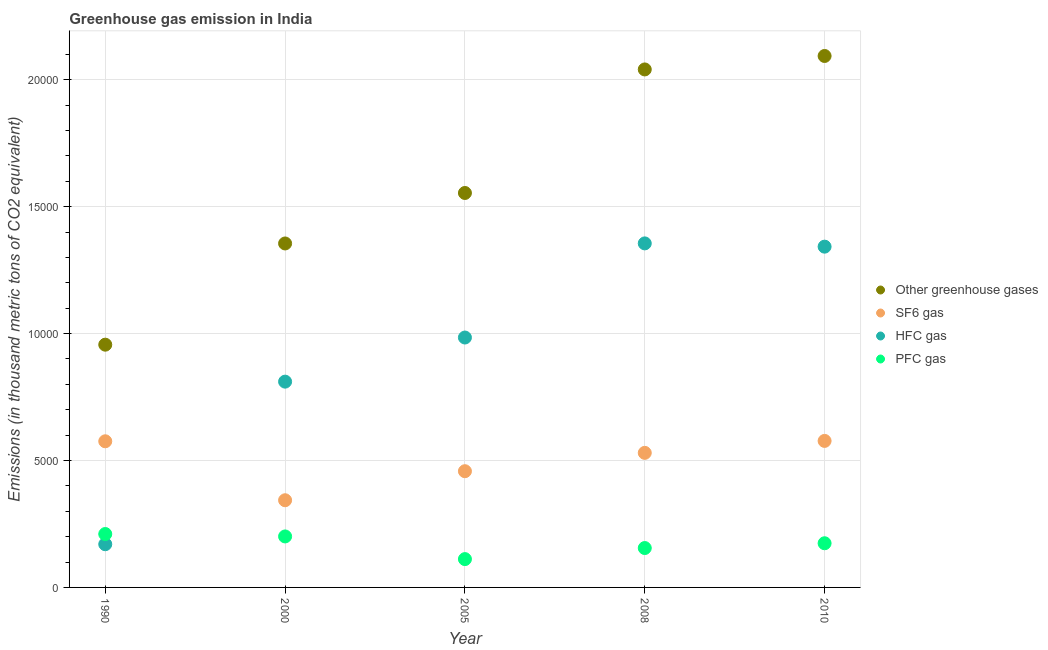Is the number of dotlines equal to the number of legend labels?
Your response must be concise. Yes. What is the emission of pfc gas in 1990?
Provide a succinct answer. 2104. Across all years, what is the maximum emission of pfc gas?
Ensure brevity in your answer.  2104. Across all years, what is the minimum emission of pfc gas?
Your answer should be compact. 1115.8. In which year was the emission of greenhouse gases maximum?
Make the answer very short. 2010. In which year was the emission of pfc gas minimum?
Provide a succinct answer. 2005. What is the total emission of sf6 gas in the graph?
Offer a very short reply. 2.48e+04. What is the difference between the emission of greenhouse gases in 1990 and that in 2008?
Your response must be concise. -1.08e+04. What is the difference between the emission of sf6 gas in 1990 and the emission of greenhouse gases in 2008?
Make the answer very short. -1.46e+04. What is the average emission of greenhouse gases per year?
Give a very brief answer. 1.60e+04. In the year 2005, what is the difference between the emission of sf6 gas and emission of greenhouse gases?
Keep it short and to the point. -1.10e+04. What is the ratio of the emission of hfc gas in 2008 to that in 2010?
Give a very brief answer. 1.01. Is the difference between the emission of pfc gas in 2000 and 2005 greater than the difference between the emission of greenhouse gases in 2000 and 2005?
Offer a terse response. Yes. What is the difference between the highest and the second highest emission of pfc gas?
Give a very brief answer. 95.2. What is the difference between the highest and the lowest emission of greenhouse gases?
Provide a succinct answer. 1.14e+04. In how many years, is the emission of pfc gas greater than the average emission of pfc gas taken over all years?
Offer a terse response. 3. Is it the case that in every year, the sum of the emission of greenhouse gases and emission of hfc gas is greater than the sum of emission of sf6 gas and emission of pfc gas?
Make the answer very short. No. Does the emission of greenhouse gases monotonically increase over the years?
Ensure brevity in your answer.  Yes. How many years are there in the graph?
Make the answer very short. 5. Are the values on the major ticks of Y-axis written in scientific E-notation?
Your answer should be compact. No. Where does the legend appear in the graph?
Provide a short and direct response. Center right. What is the title of the graph?
Make the answer very short. Greenhouse gas emission in India. Does "Social Insurance" appear as one of the legend labels in the graph?
Offer a very short reply. No. What is the label or title of the X-axis?
Your answer should be compact. Year. What is the label or title of the Y-axis?
Your response must be concise. Emissions (in thousand metric tons of CO2 equivalent). What is the Emissions (in thousand metric tons of CO2 equivalent) of Other greenhouse gases in 1990?
Give a very brief answer. 9563.6. What is the Emissions (in thousand metric tons of CO2 equivalent) in SF6 gas in 1990?
Offer a terse response. 5757.5. What is the Emissions (in thousand metric tons of CO2 equivalent) in HFC gas in 1990?
Provide a short and direct response. 1702.1. What is the Emissions (in thousand metric tons of CO2 equivalent) of PFC gas in 1990?
Offer a very short reply. 2104. What is the Emissions (in thousand metric tons of CO2 equivalent) in Other greenhouse gases in 2000?
Give a very brief answer. 1.36e+04. What is the Emissions (in thousand metric tons of CO2 equivalent) in SF6 gas in 2000?
Your response must be concise. 3434.7. What is the Emissions (in thousand metric tons of CO2 equivalent) in HFC gas in 2000?
Keep it short and to the point. 8107.2. What is the Emissions (in thousand metric tons of CO2 equivalent) in PFC gas in 2000?
Ensure brevity in your answer.  2008.8. What is the Emissions (in thousand metric tons of CO2 equivalent) in Other greenhouse gases in 2005?
Your answer should be compact. 1.55e+04. What is the Emissions (in thousand metric tons of CO2 equivalent) in SF6 gas in 2005?
Provide a succinct answer. 4578.7. What is the Emissions (in thousand metric tons of CO2 equivalent) in HFC gas in 2005?
Your answer should be compact. 9845.2. What is the Emissions (in thousand metric tons of CO2 equivalent) in PFC gas in 2005?
Offer a very short reply. 1115.8. What is the Emissions (in thousand metric tons of CO2 equivalent) in Other greenhouse gases in 2008?
Make the answer very short. 2.04e+04. What is the Emissions (in thousand metric tons of CO2 equivalent) of SF6 gas in 2008?
Give a very brief answer. 5301.4. What is the Emissions (in thousand metric tons of CO2 equivalent) in HFC gas in 2008?
Your answer should be compact. 1.36e+04. What is the Emissions (in thousand metric tons of CO2 equivalent) in PFC gas in 2008?
Provide a succinct answer. 1551.8. What is the Emissions (in thousand metric tons of CO2 equivalent) in Other greenhouse gases in 2010?
Provide a succinct answer. 2.09e+04. What is the Emissions (in thousand metric tons of CO2 equivalent) of SF6 gas in 2010?
Provide a succinct answer. 5772. What is the Emissions (in thousand metric tons of CO2 equivalent) in HFC gas in 2010?
Provide a short and direct response. 1.34e+04. What is the Emissions (in thousand metric tons of CO2 equivalent) in PFC gas in 2010?
Offer a terse response. 1740. Across all years, what is the maximum Emissions (in thousand metric tons of CO2 equivalent) of Other greenhouse gases?
Your answer should be very brief. 2.09e+04. Across all years, what is the maximum Emissions (in thousand metric tons of CO2 equivalent) of SF6 gas?
Your response must be concise. 5772. Across all years, what is the maximum Emissions (in thousand metric tons of CO2 equivalent) in HFC gas?
Offer a terse response. 1.36e+04. Across all years, what is the maximum Emissions (in thousand metric tons of CO2 equivalent) in PFC gas?
Provide a short and direct response. 2104. Across all years, what is the minimum Emissions (in thousand metric tons of CO2 equivalent) in Other greenhouse gases?
Make the answer very short. 9563.6. Across all years, what is the minimum Emissions (in thousand metric tons of CO2 equivalent) in SF6 gas?
Provide a short and direct response. 3434.7. Across all years, what is the minimum Emissions (in thousand metric tons of CO2 equivalent) in HFC gas?
Provide a succinct answer. 1702.1. Across all years, what is the minimum Emissions (in thousand metric tons of CO2 equivalent) of PFC gas?
Your response must be concise. 1115.8. What is the total Emissions (in thousand metric tons of CO2 equivalent) in Other greenhouse gases in the graph?
Offer a terse response. 8.00e+04. What is the total Emissions (in thousand metric tons of CO2 equivalent) of SF6 gas in the graph?
Your answer should be very brief. 2.48e+04. What is the total Emissions (in thousand metric tons of CO2 equivalent) in HFC gas in the graph?
Offer a very short reply. 4.66e+04. What is the total Emissions (in thousand metric tons of CO2 equivalent) in PFC gas in the graph?
Your answer should be compact. 8520.4. What is the difference between the Emissions (in thousand metric tons of CO2 equivalent) of Other greenhouse gases in 1990 and that in 2000?
Your answer should be very brief. -3987.1. What is the difference between the Emissions (in thousand metric tons of CO2 equivalent) in SF6 gas in 1990 and that in 2000?
Provide a succinct answer. 2322.8. What is the difference between the Emissions (in thousand metric tons of CO2 equivalent) in HFC gas in 1990 and that in 2000?
Make the answer very short. -6405.1. What is the difference between the Emissions (in thousand metric tons of CO2 equivalent) of PFC gas in 1990 and that in 2000?
Your answer should be compact. 95.2. What is the difference between the Emissions (in thousand metric tons of CO2 equivalent) of Other greenhouse gases in 1990 and that in 2005?
Provide a succinct answer. -5976.1. What is the difference between the Emissions (in thousand metric tons of CO2 equivalent) of SF6 gas in 1990 and that in 2005?
Provide a succinct answer. 1178.8. What is the difference between the Emissions (in thousand metric tons of CO2 equivalent) in HFC gas in 1990 and that in 2005?
Give a very brief answer. -8143.1. What is the difference between the Emissions (in thousand metric tons of CO2 equivalent) in PFC gas in 1990 and that in 2005?
Your answer should be compact. 988.2. What is the difference between the Emissions (in thousand metric tons of CO2 equivalent) in Other greenhouse gases in 1990 and that in 2008?
Keep it short and to the point. -1.08e+04. What is the difference between the Emissions (in thousand metric tons of CO2 equivalent) of SF6 gas in 1990 and that in 2008?
Keep it short and to the point. 456.1. What is the difference between the Emissions (in thousand metric tons of CO2 equivalent) in HFC gas in 1990 and that in 2008?
Ensure brevity in your answer.  -1.19e+04. What is the difference between the Emissions (in thousand metric tons of CO2 equivalent) of PFC gas in 1990 and that in 2008?
Keep it short and to the point. 552.2. What is the difference between the Emissions (in thousand metric tons of CO2 equivalent) in Other greenhouse gases in 1990 and that in 2010?
Your answer should be compact. -1.14e+04. What is the difference between the Emissions (in thousand metric tons of CO2 equivalent) of SF6 gas in 1990 and that in 2010?
Provide a succinct answer. -14.5. What is the difference between the Emissions (in thousand metric tons of CO2 equivalent) in HFC gas in 1990 and that in 2010?
Provide a succinct answer. -1.17e+04. What is the difference between the Emissions (in thousand metric tons of CO2 equivalent) of PFC gas in 1990 and that in 2010?
Make the answer very short. 364. What is the difference between the Emissions (in thousand metric tons of CO2 equivalent) in Other greenhouse gases in 2000 and that in 2005?
Your answer should be very brief. -1989. What is the difference between the Emissions (in thousand metric tons of CO2 equivalent) in SF6 gas in 2000 and that in 2005?
Your answer should be very brief. -1144. What is the difference between the Emissions (in thousand metric tons of CO2 equivalent) of HFC gas in 2000 and that in 2005?
Your response must be concise. -1738. What is the difference between the Emissions (in thousand metric tons of CO2 equivalent) in PFC gas in 2000 and that in 2005?
Your answer should be very brief. 893. What is the difference between the Emissions (in thousand metric tons of CO2 equivalent) of Other greenhouse gases in 2000 and that in 2008?
Provide a succinct answer. -6856.2. What is the difference between the Emissions (in thousand metric tons of CO2 equivalent) of SF6 gas in 2000 and that in 2008?
Provide a succinct answer. -1866.7. What is the difference between the Emissions (in thousand metric tons of CO2 equivalent) in HFC gas in 2000 and that in 2008?
Offer a terse response. -5446.5. What is the difference between the Emissions (in thousand metric tons of CO2 equivalent) of PFC gas in 2000 and that in 2008?
Provide a short and direct response. 457. What is the difference between the Emissions (in thousand metric tons of CO2 equivalent) of Other greenhouse gases in 2000 and that in 2010?
Make the answer very short. -7386.3. What is the difference between the Emissions (in thousand metric tons of CO2 equivalent) in SF6 gas in 2000 and that in 2010?
Ensure brevity in your answer.  -2337.3. What is the difference between the Emissions (in thousand metric tons of CO2 equivalent) in HFC gas in 2000 and that in 2010?
Your answer should be compact. -5317.8. What is the difference between the Emissions (in thousand metric tons of CO2 equivalent) in PFC gas in 2000 and that in 2010?
Offer a terse response. 268.8. What is the difference between the Emissions (in thousand metric tons of CO2 equivalent) in Other greenhouse gases in 2005 and that in 2008?
Your response must be concise. -4867.2. What is the difference between the Emissions (in thousand metric tons of CO2 equivalent) in SF6 gas in 2005 and that in 2008?
Make the answer very short. -722.7. What is the difference between the Emissions (in thousand metric tons of CO2 equivalent) of HFC gas in 2005 and that in 2008?
Provide a succinct answer. -3708.5. What is the difference between the Emissions (in thousand metric tons of CO2 equivalent) of PFC gas in 2005 and that in 2008?
Your answer should be compact. -436. What is the difference between the Emissions (in thousand metric tons of CO2 equivalent) of Other greenhouse gases in 2005 and that in 2010?
Your answer should be very brief. -5397.3. What is the difference between the Emissions (in thousand metric tons of CO2 equivalent) of SF6 gas in 2005 and that in 2010?
Your answer should be compact. -1193.3. What is the difference between the Emissions (in thousand metric tons of CO2 equivalent) in HFC gas in 2005 and that in 2010?
Offer a terse response. -3579.8. What is the difference between the Emissions (in thousand metric tons of CO2 equivalent) of PFC gas in 2005 and that in 2010?
Provide a succinct answer. -624.2. What is the difference between the Emissions (in thousand metric tons of CO2 equivalent) in Other greenhouse gases in 2008 and that in 2010?
Your answer should be very brief. -530.1. What is the difference between the Emissions (in thousand metric tons of CO2 equivalent) of SF6 gas in 2008 and that in 2010?
Provide a succinct answer. -470.6. What is the difference between the Emissions (in thousand metric tons of CO2 equivalent) in HFC gas in 2008 and that in 2010?
Your answer should be very brief. 128.7. What is the difference between the Emissions (in thousand metric tons of CO2 equivalent) in PFC gas in 2008 and that in 2010?
Your response must be concise. -188.2. What is the difference between the Emissions (in thousand metric tons of CO2 equivalent) in Other greenhouse gases in 1990 and the Emissions (in thousand metric tons of CO2 equivalent) in SF6 gas in 2000?
Your response must be concise. 6128.9. What is the difference between the Emissions (in thousand metric tons of CO2 equivalent) in Other greenhouse gases in 1990 and the Emissions (in thousand metric tons of CO2 equivalent) in HFC gas in 2000?
Your response must be concise. 1456.4. What is the difference between the Emissions (in thousand metric tons of CO2 equivalent) in Other greenhouse gases in 1990 and the Emissions (in thousand metric tons of CO2 equivalent) in PFC gas in 2000?
Your response must be concise. 7554.8. What is the difference between the Emissions (in thousand metric tons of CO2 equivalent) in SF6 gas in 1990 and the Emissions (in thousand metric tons of CO2 equivalent) in HFC gas in 2000?
Provide a short and direct response. -2349.7. What is the difference between the Emissions (in thousand metric tons of CO2 equivalent) in SF6 gas in 1990 and the Emissions (in thousand metric tons of CO2 equivalent) in PFC gas in 2000?
Offer a very short reply. 3748.7. What is the difference between the Emissions (in thousand metric tons of CO2 equivalent) of HFC gas in 1990 and the Emissions (in thousand metric tons of CO2 equivalent) of PFC gas in 2000?
Offer a very short reply. -306.7. What is the difference between the Emissions (in thousand metric tons of CO2 equivalent) of Other greenhouse gases in 1990 and the Emissions (in thousand metric tons of CO2 equivalent) of SF6 gas in 2005?
Make the answer very short. 4984.9. What is the difference between the Emissions (in thousand metric tons of CO2 equivalent) of Other greenhouse gases in 1990 and the Emissions (in thousand metric tons of CO2 equivalent) of HFC gas in 2005?
Your answer should be compact. -281.6. What is the difference between the Emissions (in thousand metric tons of CO2 equivalent) of Other greenhouse gases in 1990 and the Emissions (in thousand metric tons of CO2 equivalent) of PFC gas in 2005?
Offer a terse response. 8447.8. What is the difference between the Emissions (in thousand metric tons of CO2 equivalent) in SF6 gas in 1990 and the Emissions (in thousand metric tons of CO2 equivalent) in HFC gas in 2005?
Provide a short and direct response. -4087.7. What is the difference between the Emissions (in thousand metric tons of CO2 equivalent) in SF6 gas in 1990 and the Emissions (in thousand metric tons of CO2 equivalent) in PFC gas in 2005?
Your answer should be very brief. 4641.7. What is the difference between the Emissions (in thousand metric tons of CO2 equivalent) of HFC gas in 1990 and the Emissions (in thousand metric tons of CO2 equivalent) of PFC gas in 2005?
Make the answer very short. 586.3. What is the difference between the Emissions (in thousand metric tons of CO2 equivalent) of Other greenhouse gases in 1990 and the Emissions (in thousand metric tons of CO2 equivalent) of SF6 gas in 2008?
Give a very brief answer. 4262.2. What is the difference between the Emissions (in thousand metric tons of CO2 equivalent) of Other greenhouse gases in 1990 and the Emissions (in thousand metric tons of CO2 equivalent) of HFC gas in 2008?
Make the answer very short. -3990.1. What is the difference between the Emissions (in thousand metric tons of CO2 equivalent) in Other greenhouse gases in 1990 and the Emissions (in thousand metric tons of CO2 equivalent) in PFC gas in 2008?
Offer a very short reply. 8011.8. What is the difference between the Emissions (in thousand metric tons of CO2 equivalent) of SF6 gas in 1990 and the Emissions (in thousand metric tons of CO2 equivalent) of HFC gas in 2008?
Give a very brief answer. -7796.2. What is the difference between the Emissions (in thousand metric tons of CO2 equivalent) of SF6 gas in 1990 and the Emissions (in thousand metric tons of CO2 equivalent) of PFC gas in 2008?
Offer a very short reply. 4205.7. What is the difference between the Emissions (in thousand metric tons of CO2 equivalent) of HFC gas in 1990 and the Emissions (in thousand metric tons of CO2 equivalent) of PFC gas in 2008?
Provide a succinct answer. 150.3. What is the difference between the Emissions (in thousand metric tons of CO2 equivalent) in Other greenhouse gases in 1990 and the Emissions (in thousand metric tons of CO2 equivalent) in SF6 gas in 2010?
Provide a short and direct response. 3791.6. What is the difference between the Emissions (in thousand metric tons of CO2 equivalent) in Other greenhouse gases in 1990 and the Emissions (in thousand metric tons of CO2 equivalent) in HFC gas in 2010?
Keep it short and to the point. -3861.4. What is the difference between the Emissions (in thousand metric tons of CO2 equivalent) of Other greenhouse gases in 1990 and the Emissions (in thousand metric tons of CO2 equivalent) of PFC gas in 2010?
Provide a short and direct response. 7823.6. What is the difference between the Emissions (in thousand metric tons of CO2 equivalent) in SF6 gas in 1990 and the Emissions (in thousand metric tons of CO2 equivalent) in HFC gas in 2010?
Provide a short and direct response. -7667.5. What is the difference between the Emissions (in thousand metric tons of CO2 equivalent) in SF6 gas in 1990 and the Emissions (in thousand metric tons of CO2 equivalent) in PFC gas in 2010?
Give a very brief answer. 4017.5. What is the difference between the Emissions (in thousand metric tons of CO2 equivalent) in HFC gas in 1990 and the Emissions (in thousand metric tons of CO2 equivalent) in PFC gas in 2010?
Offer a very short reply. -37.9. What is the difference between the Emissions (in thousand metric tons of CO2 equivalent) in Other greenhouse gases in 2000 and the Emissions (in thousand metric tons of CO2 equivalent) in SF6 gas in 2005?
Provide a short and direct response. 8972. What is the difference between the Emissions (in thousand metric tons of CO2 equivalent) of Other greenhouse gases in 2000 and the Emissions (in thousand metric tons of CO2 equivalent) of HFC gas in 2005?
Offer a terse response. 3705.5. What is the difference between the Emissions (in thousand metric tons of CO2 equivalent) of Other greenhouse gases in 2000 and the Emissions (in thousand metric tons of CO2 equivalent) of PFC gas in 2005?
Offer a terse response. 1.24e+04. What is the difference between the Emissions (in thousand metric tons of CO2 equivalent) in SF6 gas in 2000 and the Emissions (in thousand metric tons of CO2 equivalent) in HFC gas in 2005?
Keep it short and to the point. -6410.5. What is the difference between the Emissions (in thousand metric tons of CO2 equivalent) in SF6 gas in 2000 and the Emissions (in thousand metric tons of CO2 equivalent) in PFC gas in 2005?
Ensure brevity in your answer.  2318.9. What is the difference between the Emissions (in thousand metric tons of CO2 equivalent) of HFC gas in 2000 and the Emissions (in thousand metric tons of CO2 equivalent) of PFC gas in 2005?
Keep it short and to the point. 6991.4. What is the difference between the Emissions (in thousand metric tons of CO2 equivalent) in Other greenhouse gases in 2000 and the Emissions (in thousand metric tons of CO2 equivalent) in SF6 gas in 2008?
Provide a short and direct response. 8249.3. What is the difference between the Emissions (in thousand metric tons of CO2 equivalent) in Other greenhouse gases in 2000 and the Emissions (in thousand metric tons of CO2 equivalent) in PFC gas in 2008?
Offer a very short reply. 1.20e+04. What is the difference between the Emissions (in thousand metric tons of CO2 equivalent) in SF6 gas in 2000 and the Emissions (in thousand metric tons of CO2 equivalent) in HFC gas in 2008?
Your response must be concise. -1.01e+04. What is the difference between the Emissions (in thousand metric tons of CO2 equivalent) in SF6 gas in 2000 and the Emissions (in thousand metric tons of CO2 equivalent) in PFC gas in 2008?
Keep it short and to the point. 1882.9. What is the difference between the Emissions (in thousand metric tons of CO2 equivalent) of HFC gas in 2000 and the Emissions (in thousand metric tons of CO2 equivalent) of PFC gas in 2008?
Ensure brevity in your answer.  6555.4. What is the difference between the Emissions (in thousand metric tons of CO2 equivalent) of Other greenhouse gases in 2000 and the Emissions (in thousand metric tons of CO2 equivalent) of SF6 gas in 2010?
Provide a succinct answer. 7778.7. What is the difference between the Emissions (in thousand metric tons of CO2 equivalent) in Other greenhouse gases in 2000 and the Emissions (in thousand metric tons of CO2 equivalent) in HFC gas in 2010?
Offer a terse response. 125.7. What is the difference between the Emissions (in thousand metric tons of CO2 equivalent) in Other greenhouse gases in 2000 and the Emissions (in thousand metric tons of CO2 equivalent) in PFC gas in 2010?
Your response must be concise. 1.18e+04. What is the difference between the Emissions (in thousand metric tons of CO2 equivalent) of SF6 gas in 2000 and the Emissions (in thousand metric tons of CO2 equivalent) of HFC gas in 2010?
Your answer should be very brief. -9990.3. What is the difference between the Emissions (in thousand metric tons of CO2 equivalent) of SF6 gas in 2000 and the Emissions (in thousand metric tons of CO2 equivalent) of PFC gas in 2010?
Offer a very short reply. 1694.7. What is the difference between the Emissions (in thousand metric tons of CO2 equivalent) in HFC gas in 2000 and the Emissions (in thousand metric tons of CO2 equivalent) in PFC gas in 2010?
Your response must be concise. 6367.2. What is the difference between the Emissions (in thousand metric tons of CO2 equivalent) in Other greenhouse gases in 2005 and the Emissions (in thousand metric tons of CO2 equivalent) in SF6 gas in 2008?
Offer a very short reply. 1.02e+04. What is the difference between the Emissions (in thousand metric tons of CO2 equivalent) in Other greenhouse gases in 2005 and the Emissions (in thousand metric tons of CO2 equivalent) in HFC gas in 2008?
Provide a succinct answer. 1986. What is the difference between the Emissions (in thousand metric tons of CO2 equivalent) of Other greenhouse gases in 2005 and the Emissions (in thousand metric tons of CO2 equivalent) of PFC gas in 2008?
Keep it short and to the point. 1.40e+04. What is the difference between the Emissions (in thousand metric tons of CO2 equivalent) of SF6 gas in 2005 and the Emissions (in thousand metric tons of CO2 equivalent) of HFC gas in 2008?
Offer a terse response. -8975. What is the difference between the Emissions (in thousand metric tons of CO2 equivalent) in SF6 gas in 2005 and the Emissions (in thousand metric tons of CO2 equivalent) in PFC gas in 2008?
Give a very brief answer. 3026.9. What is the difference between the Emissions (in thousand metric tons of CO2 equivalent) of HFC gas in 2005 and the Emissions (in thousand metric tons of CO2 equivalent) of PFC gas in 2008?
Make the answer very short. 8293.4. What is the difference between the Emissions (in thousand metric tons of CO2 equivalent) of Other greenhouse gases in 2005 and the Emissions (in thousand metric tons of CO2 equivalent) of SF6 gas in 2010?
Offer a very short reply. 9767.7. What is the difference between the Emissions (in thousand metric tons of CO2 equivalent) of Other greenhouse gases in 2005 and the Emissions (in thousand metric tons of CO2 equivalent) of HFC gas in 2010?
Offer a very short reply. 2114.7. What is the difference between the Emissions (in thousand metric tons of CO2 equivalent) in Other greenhouse gases in 2005 and the Emissions (in thousand metric tons of CO2 equivalent) in PFC gas in 2010?
Your answer should be very brief. 1.38e+04. What is the difference between the Emissions (in thousand metric tons of CO2 equivalent) of SF6 gas in 2005 and the Emissions (in thousand metric tons of CO2 equivalent) of HFC gas in 2010?
Your answer should be compact. -8846.3. What is the difference between the Emissions (in thousand metric tons of CO2 equivalent) in SF6 gas in 2005 and the Emissions (in thousand metric tons of CO2 equivalent) in PFC gas in 2010?
Provide a short and direct response. 2838.7. What is the difference between the Emissions (in thousand metric tons of CO2 equivalent) in HFC gas in 2005 and the Emissions (in thousand metric tons of CO2 equivalent) in PFC gas in 2010?
Your answer should be compact. 8105.2. What is the difference between the Emissions (in thousand metric tons of CO2 equivalent) of Other greenhouse gases in 2008 and the Emissions (in thousand metric tons of CO2 equivalent) of SF6 gas in 2010?
Keep it short and to the point. 1.46e+04. What is the difference between the Emissions (in thousand metric tons of CO2 equivalent) in Other greenhouse gases in 2008 and the Emissions (in thousand metric tons of CO2 equivalent) in HFC gas in 2010?
Your answer should be compact. 6981.9. What is the difference between the Emissions (in thousand metric tons of CO2 equivalent) of Other greenhouse gases in 2008 and the Emissions (in thousand metric tons of CO2 equivalent) of PFC gas in 2010?
Offer a very short reply. 1.87e+04. What is the difference between the Emissions (in thousand metric tons of CO2 equivalent) in SF6 gas in 2008 and the Emissions (in thousand metric tons of CO2 equivalent) in HFC gas in 2010?
Make the answer very short. -8123.6. What is the difference between the Emissions (in thousand metric tons of CO2 equivalent) of SF6 gas in 2008 and the Emissions (in thousand metric tons of CO2 equivalent) of PFC gas in 2010?
Provide a succinct answer. 3561.4. What is the difference between the Emissions (in thousand metric tons of CO2 equivalent) of HFC gas in 2008 and the Emissions (in thousand metric tons of CO2 equivalent) of PFC gas in 2010?
Ensure brevity in your answer.  1.18e+04. What is the average Emissions (in thousand metric tons of CO2 equivalent) in Other greenhouse gases per year?
Ensure brevity in your answer.  1.60e+04. What is the average Emissions (in thousand metric tons of CO2 equivalent) of SF6 gas per year?
Provide a short and direct response. 4968.86. What is the average Emissions (in thousand metric tons of CO2 equivalent) in HFC gas per year?
Your response must be concise. 9326.64. What is the average Emissions (in thousand metric tons of CO2 equivalent) of PFC gas per year?
Ensure brevity in your answer.  1704.08. In the year 1990, what is the difference between the Emissions (in thousand metric tons of CO2 equivalent) of Other greenhouse gases and Emissions (in thousand metric tons of CO2 equivalent) of SF6 gas?
Provide a succinct answer. 3806.1. In the year 1990, what is the difference between the Emissions (in thousand metric tons of CO2 equivalent) of Other greenhouse gases and Emissions (in thousand metric tons of CO2 equivalent) of HFC gas?
Give a very brief answer. 7861.5. In the year 1990, what is the difference between the Emissions (in thousand metric tons of CO2 equivalent) in Other greenhouse gases and Emissions (in thousand metric tons of CO2 equivalent) in PFC gas?
Your response must be concise. 7459.6. In the year 1990, what is the difference between the Emissions (in thousand metric tons of CO2 equivalent) in SF6 gas and Emissions (in thousand metric tons of CO2 equivalent) in HFC gas?
Offer a terse response. 4055.4. In the year 1990, what is the difference between the Emissions (in thousand metric tons of CO2 equivalent) in SF6 gas and Emissions (in thousand metric tons of CO2 equivalent) in PFC gas?
Your response must be concise. 3653.5. In the year 1990, what is the difference between the Emissions (in thousand metric tons of CO2 equivalent) of HFC gas and Emissions (in thousand metric tons of CO2 equivalent) of PFC gas?
Your answer should be compact. -401.9. In the year 2000, what is the difference between the Emissions (in thousand metric tons of CO2 equivalent) in Other greenhouse gases and Emissions (in thousand metric tons of CO2 equivalent) in SF6 gas?
Make the answer very short. 1.01e+04. In the year 2000, what is the difference between the Emissions (in thousand metric tons of CO2 equivalent) of Other greenhouse gases and Emissions (in thousand metric tons of CO2 equivalent) of HFC gas?
Your response must be concise. 5443.5. In the year 2000, what is the difference between the Emissions (in thousand metric tons of CO2 equivalent) of Other greenhouse gases and Emissions (in thousand metric tons of CO2 equivalent) of PFC gas?
Keep it short and to the point. 1.15e+04. In the year 2000, what is the difference between the Emissions (in thousand metric tons of CO2 equivalent) of SF6 gas and Emissions (in thousand metric tons of CO2 equivalent) of HFC gas?
Offer a terse response. -4672.5. In the year 2000, what is the difference between the Emissions (in thousand metric tons of CO2 equivalent) in SF6 gas and Emissions (in thousand metric tons of CO2 equivalent) in PFC gas?
Your answer should be very brief. 1425.9. In the year 2000, what is the difference between the Emissions (in thousand metric tons of CO2 equivalent) of HFC gas and Emissions (in thousand metric tons of CO2 equivalent) of PFC gas?
Your response must be concise. 6098.4. In the year 2005, what is the difference between the Emissions (in thousand metric tons of CO2 equivalent) of Other greenhouse gases and Emissions (in thousand metric tons of CO2 equivalent) of SF6 gas?
Make the answer very short. 1.10e+04. In the year 2005, what is the difference between the Emissions (in thousand metric tons of CO2 equivalent) in Other greenhouse gases and Emissions (in thousand metric tons of CO2 equivalent) in HFC gas?
Ensure brevity in your answer.  5694.5. In the year 2005, what is the difference between the Emissions (in thousand metric tons of CO2 equivalent) of Other greenhouse gases and Emissions (in thousand metric tons of CO2 equivalent) of PFC gas?
Ensure brevity in your answer.  1.44e+04. In the year 2005, what is the difference between the Emissions (in thousand metric tons of CO2 equivalent) in SF6 gas and Emissions (in thousand metric tons of CO2 equivalent) in HFC gas?
Ensure brevity in your answer.  -5266.5. In the year 2005, what is the difference between the Emissions (in thousand metric tons of CO2 equivalent) of SF6 gas and Emissions (in thousand metric tons of CO2 equivalent) of PFC gas?
Make the answer very short. 3462.9. In the year 2005, what is the difference between the Emissions (in thousand metric tons of CO2 equivalent) of HFC gas and Emissions (in thousand metric tons of CO2 equivalent) of PFC gas?
Provide a short and direct response. 8729.4. In the year 2008, what is the difference between the Emissions (in thousand metric tons of CO2 equivalent) in Other greenhouse gases and Emissions (in thousand metric tons of CO2 equivalent) in SF6 gas?
Ensure brevity in your answer.  1.51e+04. In the year 2008, what is the difference between the Emissions (in thousand metric tons of CO2 equivalent) in Other greenhouse gases and Emissions (in thousand metric tons of CO2 equivalent) in HFC gas?
Ensure brevity in your answer.  6853.2. In the year 2008, what is the difference between the Emissions (in thousand metric tons of CO2 equivalent) of Other greenhouse gases and Emissions (in thousand metric tons of CO2 equivalent) of PFC gas?
Your answer should be very brief. 1.89e+04. In the year 2008, what is the difference between the Emissions (in thousand metric tons of CO2 equivalent) in SF6 gas and Emissions (in thousand metric tons of CO2 equivalent) in HFC gas?
Give a very brief answer. -8252.3. In the year 2008, what is the difference between the Emissions (in thousand metric tons of CO2 equivalent) in SF6 gas and Emissions (in thousand metric tons of CO2 equivalent) in PFC gas?
Your answer should be compact. 3749.6. In the year 2008, what is the difference between the Emissions (in thousand metric tons of CO2 equivalent) in HFC gas and Emissions (in thousand metric tons of CO2 equivalent) in PFC gas?
Your answer should be very brief. 1.20e+04. In the year 2010, what is the difference between the Emissions (in thousand metric tons of CO2 equivalent) in Other greenhouse gases and Emissions (in thousand metric tons of CO2 equivalent) in SF6 gas?
Your response must be concise. 1.52e+04. In the year 2010, what is the difference between the Emissions (in thousand metric tons of CO2 equivalent) in Other greenhouse gases and Emissions (in thousand metric tons of CO2 equivalent) in HFC gas?
Provide a short and direct response. 7512. In the year 2010, what is the difference between the Emissions (in thousand metric tons of CO2 equivalent) in Other greenhouse gases and Emissions (in thousand metric tons of CO2 equivalent) in PFC gas?
Ensure brevity in your answer.  1.92e+04. In the year 2010, what is the difference between the Emissions (in thousand metric tons of CO2 equivalent) of SF6 gas and Emissions (in thousand metric tons of CO2 equivalent) of HFC gas?
Your response must be concise. -7653. In the year 2010, what is the difference between the Emissions (in thousand metric tons of CO2 equivalent) in SF6 gas and Emissions (in thousand metric tons of CO2 equivalent) in PFC gas?
Offer a very short reply. 4032. In the year 2010, what is the difference between the Emissions (in thousand metric tons of CO2 equivalent) in HFC gas and Emissions (in thousand metric tons of CO2 equivalent) in PFC gas?
Your response must be concise. 1.17e+04. What is the ratio of the Emissions (in thousand metric tons of CO2 equivalent) of Other greenhouse gases in 1990 to that in 2000?
Give a very brief answer. 0.71. What is the ratio of the Emissions (in thousand metric tons of CO2 equivalent) in SF6 gas in 1990 to that in 2000?
Give a very brief answer. 1.68. What is the ratio of the Emissions (in thousand metric tons of CO2 equivalent) of HFC gas in 1990 to that in 2000?
Ensure brevity in your answer.  0.21. What is the ratio of the Emissions (in thousand metric tons of CO2 equivalent) in PFC gas in 1990 to that in 2000?
Offer a terse response. 1.05. What is the ratio of the Emissions (in thousand metric tons of CO2 equivalent) of Other greenhouse gases in 1990 to that in 2005?
Offer a very short reply. 0.62. What is the ratio of the Emissions (in thousand metric tons of CO2 equivalent) in SF6 gas in 1990 to that in 2005?
Make the answer very short. 1.26. What is the ratio of the Emissions (in thousand metric tons of CO2 equivalent) in HFC gas in 1990 to that in 2005?
Give a very brief answer. 0.17. What is the ratio of the Emissions (in thousand metric tons of CO2 equivalent) in PFC gas in 1990 to that in 2005?
Your response must be concise. 1.89. What is the ratio of the Emissions (in thousand metric tons of CO2 equivalent) in Other greenhouse gases in 1990 to that in 2008?
Your answer should be compact. 0.47. What is the ratio of the Emissions (in thousand metric tons of CO2 equivalent) of SF6 gas in 1990 to that in 2008?
Make the answer very short. 1.09. What is the ratio of the Emissions (in thousand metric tons of CO2 equivalent) of HFC gas in 1990 to that in 2008?
Provide a short and direct response. 0.13. What is the ratio of the Emissions (in thousand metric tons of CO2 equivalent) of PFC gas in 1990 to that in 2008?
Your answer should be compact. 1.36. What is the ratio of the Emissions (in thousand metric tons of CO2 equivalent) of Other greenhouse gases in 1990 to that in 2010?
Offer a very short reply. 0.46. What is the ratio of the Emissions (in thousand metric tons of CO2 equivalent) in HFC gas in 1990 to that in 2010?
Your response must be concise. 0.13. What is the ratio of the Emissions (in thousand metric tons of CO2 equivalent) of PFC gas in 1990 to that in 2010?
Keep it short and to the point. 1.21. What is the ratio of the Emissions (in thousand metric tons of CO2 equivalent) in Other greenhouse gases in 2000 to that in 2005?
Your response must be concise. 0.87. What is the ratio of the Emissions (in thousand metric tons of CO2 equivalent) in SF6 gas in 2000 to that in 2005?
Make the answer very short. 0.75. What is the ratio of the Emissions (in thousand metric tons of CO2 equivalent) of HFC gas in 2000 to that in 2005?
Keep it short and to the point. 0.82. What is the ratio of the Emissions (in thousand metric tons of CO2 equivalent) in PFC gas in 2000 to that in 2005?
Offer a terse response. 1.8. What is the ratio of the Emissions (in thousand metric tons of CO2 equivalent) of Other greenhouse gases in 2000 to that in 2008?
Offer a very short reply. 0.66. What is the ratio of the Emissions (in thousand metric tons of CO2 equivalent) of SF6 gas in 2000 to that in 2008?
Your response must be concise. 0.65. What is the ratio of the Emissions (in thousand metric tons of CO2 equivalent) in HFC gas in 2000 to that in 2008?
Offer a terse response. 0.6. What is the ratio of the Emissions (in thousand metric tons of CO2 equivalent) of PFC gas in 2000 to that in 2008?
Keep it short and to the point. 1.29. What is the ratio of the Emissions (in thousand metric tons of CO2 equivalent) of Other greenhouse gases in 2000 to that in 2010?
Ensure brevity in your answer.  0.65. What is the ratio of the Emissions (in thousand metric tons of CO2 equivalent) in SF6 gas in 2000 to that in 2010?
Provide a short and direct response. 0.6. What is the ratio of the Emissions (in thousand metric tons of CO2 equivalent) in HFC gas in 2000 to that in 2010?
Ensure brevity in your answer.  0.6. What is the ratio of the Emissions (in thousand metric tons of CO2 equivalent) of PFC gas in 2000 to that in 2010?
Give a very brief answer. 1.15. What is the ratio of the Emissions (in thousand metric tons of CO2 equivalent) of Other greenhouse gases in 2005 to that in 2008?
Make the answer very short. 0.76. What is the ratio of the Emissions (in thousand metric tons of CO2 equivalent) of SF6 gas in 2005 to that in 2008?
Give a very brief answer. 0.86. What is the ratio of the Emissions (in thousand metric tons of CO2 equivalent) of HFC gas in 2005 to that in 2008?
Offer a terse response. 0.73. What is the ratio of the Emissions (in thousand metric tons of CO2 equivalent) in PFC gas in 2005 to that in 2008?
Make the answer very short. 0.72. What is the ratio of the Emissions (in thousand metric tons of CO2 equivalent) in Other greenhouse gases in 2005 to that in 2010?
Offer a very short reply. 0.74. What is the ratio of the Emissions (in thousand metric tons of CO2 equivalent) in SF6 gas in 2005 to that in 2010?
Make the answer very short. 0.79. What is the ratio of the Emissions (in thousand metric tons of CO2 equivalent) in HFC gas in 2005 to that in 2010?
Your response must be concise. 0.73. What is the ratio of the Emissions (in thousand metric tons of CO2 equivalent) of PFC gas in 2005 to that in 2010?
Provide a succinct answer. 0.64. What is the ratio of the Emissions (in thousand metric tons of CO2 equivalent) in Other greenhouse gases in 2008 to that in 2010?
Your answer should be very brief. 0.97. What is the ratio of the Emissions (in thousand metric tons of CO2 equivalent) of SF6 gas in 2008 to that in 2010?
Provide a succinct answer. 0.92. What is the ratio of the Emissions (in thousand metric tons of CO2 equivalent) of HFC gas in 2008 to that in 2010?
Your answer should be compact. 1.01. What is the ratio of the Emissions (in thousand metric tons of CO2 equivalent) of PFC gas in 2008 to that in 2010?
Offer a very short reply. 0.89. What is the difference between the highest and the second highest Emissions (in thousand metric tons of CO2 equivalent) of Other greenhouse gases?
Keep it short and to the point. 530.1. What is the difference between the highest and the second highest Emissions (in thousand metric tons of CO2 equivalent) in HFC gas?
Ensure brevity in your answer.  128.7. What is the difference between the highest and the second highest Emissions (in thousand metric tons of CO2 equivalent) of PFC gas?
Give a very brief answer. 95.2. What is the difference between the highest and the lowest Emissions (in thousand metric tons of CO2 equivalent) of Other greenhouse gases?
Provide a succinct answer. 1.14e+04. What is the difference between the highest and the lowest Emissions (in thousand metric tons of CO2 equivalent) of SF6 gas?
Your response must be concise. 2337.3. What is the difference between the highest and the lowest Emissions (in thousand metric tons of CO2 equivalent) in HFC gas?
Provide a succinct answer. 1.19e+04. What is the difference between the highest and the lowest Emissions (in thousand metric tons of CO2 equivalent) of PFC gas?
Keep it short and to the point. 988.2. 